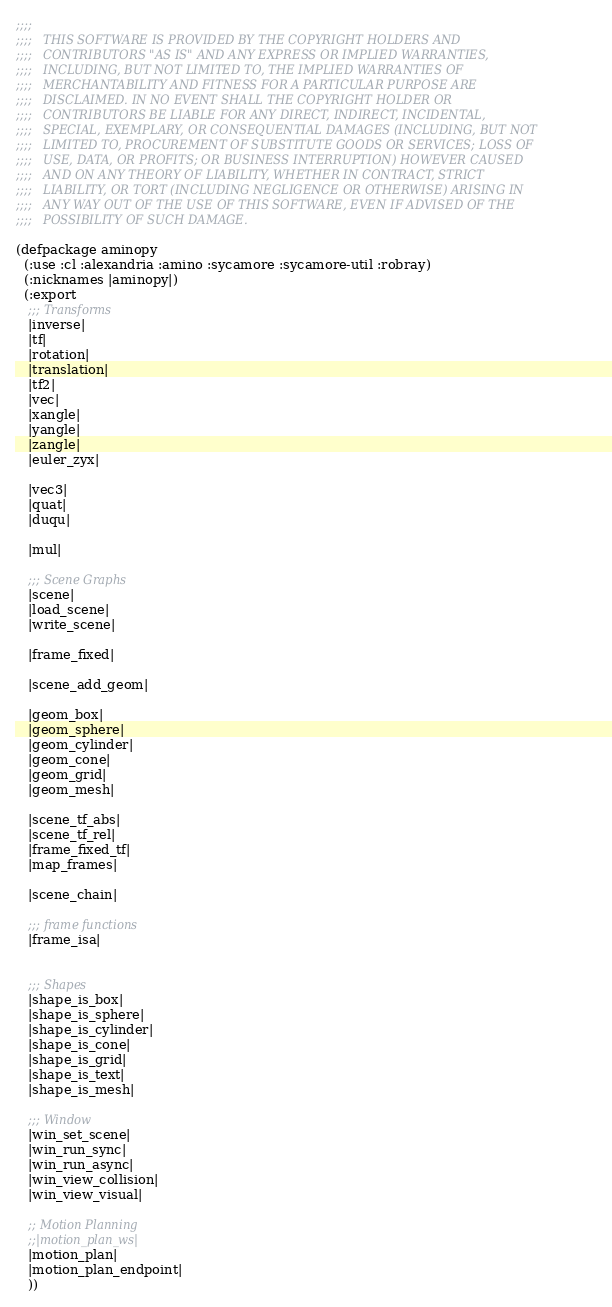<code> <loc_0><loc_0><loc_500><loc_500><_Lisp_>;;;;
;;;;   THIS SOFTWARE IS PROVIDED BY THE COPYRIGHT HOLDERS AND
;;;;   CONTRIBUTORS "AS IS" AND ANY EXPRESS OR IMPLIED WARRANTIES,
;;;;   INCLUDING, BUT NOT LIMITED TO, THE IMPLIED WARRANTIES OF
;;;;   MERCHANTABILITY AND FITNESS FOR A PARTICULAR PURPOSE ARE
;;;;   DISCLAIMED. IN NO EVENT SHALL THE COPYRIGHT HOLDER OR
;;;;   CONTRIBUTORS BE LIABLE FOR ANY DIRECT, INDIRECT, INCIDENTAL,
;;;;   SPECIAL, EXEMPLARY, OR CONSEQUENTIAL DAMAGES (INCLUDING, BUT NOT
;;;;   LIMITED TO, PROCUREMENT OF SUBSTITUTE GOODS OR SERVICES; LOSS OF
;;;;   USE, DATA, OR PROFITS; OR BUSINESS INTERRUPTION) HOWEVER CAUSED
;;;;   AND ON ANY THEORY OF LIABILITY, WHETHER IN CONTRACT, STRICT
;;;;   LIABILITY, OR TORT (INCLUDING NEGLIGENCE OR OTHERWISE) ARISING IN
;;;;   ANY WAY OUT OF THE USE OF THIS SOFTWARE, EVEN IF ADVISED OF THE
;;;;   POSSIBILITY OF SUCH DAMAGE.

(defpackage aminopy
  (:use :cl :alexandria :amino :sycamore :sycamore-util :robray)
  (:nicknames |aminopy|)
  (:export
   ;;; Transforms
   |inverse|
   |tf|
   |rotation|
   |translation|
   |tf2|
   |vec|
   |xangle|
   |yangle|
   |zangle|
   |euler_zyx|

   |vec3|
   |quat|
   |duqu|

   |mul|

   ;;; Scene Graphs
   |scene|
   |load_scene|
   |write_scene|

   |frame_fixed|

   |scene_add_geom|

   |geom_box|
   |geom_sphere|
   |geom_cylinder|
   |geom_cone|
   |geom_grid|
   |geom_mesh|

   |scene_tf_abs|
   |scene_tf_rel|
   |frame_fixed_tf|
   |map_frames|

   |scene_chain|

   ;;; frame functions
   |frame_isa|


   ;;; Shapes
   |shape_is_box|
   |shape_is_sphere|
   |shape_is_cylinder|
   |shape_is_cone|
   |shape_is_grid|
   |shape_is_text|
   |shape_is_mesh|

   ;;; Window
   |win_set_scene|
   |win_run_sync|
   |win_run_async|
   |win_view_collision|
   |win_view_visual|

   ;; Motion Planning
   ;;|motion_plan_ws|
   |motion_plan|
   |motion_plan_endpoint|
   ))
</code> 